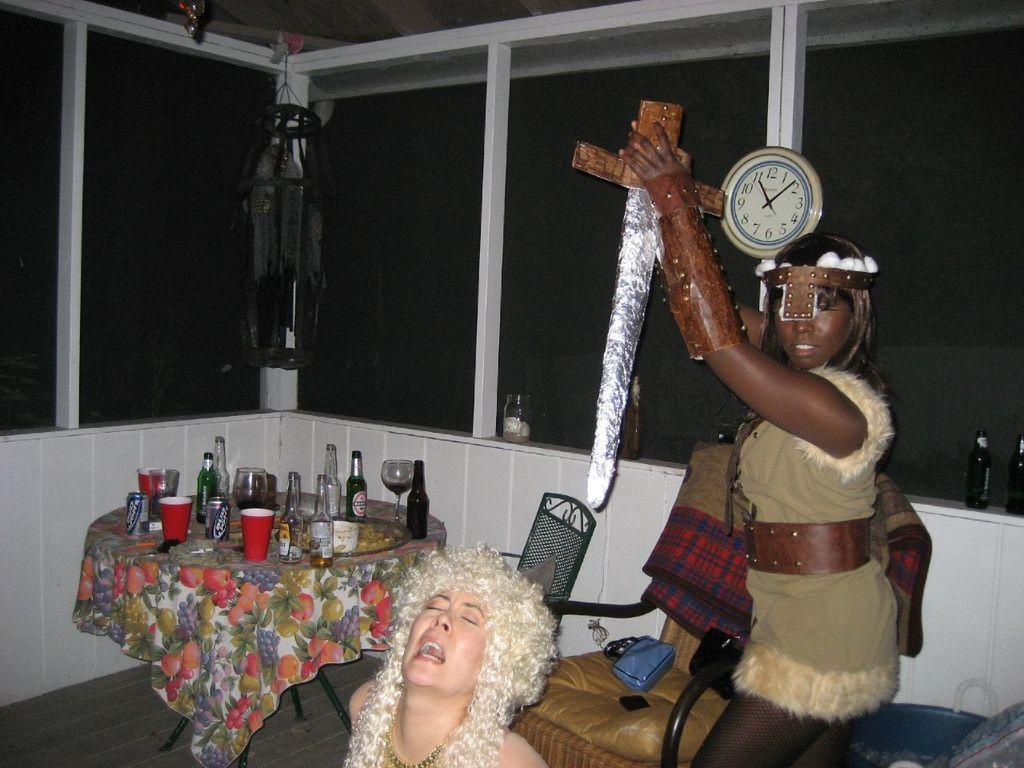<image>
Share a concise interpretation of the image provided. Woman that is holding up a fake sword, with another woman that is like yelling in pain, clock in background that says 11:08. 